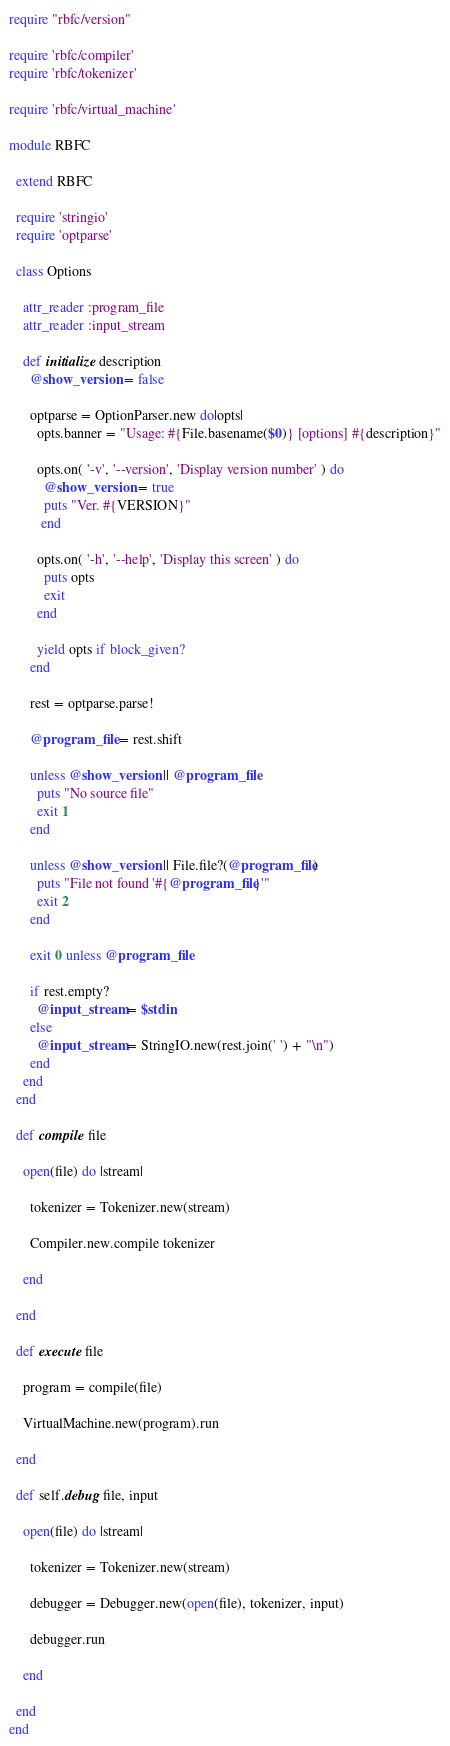Convert code to text. <code><loc_0><loc_0><loc_500><loc_500><_Ruby_>require "rbfc/version"

require 'rbfc/compiler'
require 'rbfc/tokenizer'

require 'rbfc/virtual_machine'

module RBFC

  extend RBFC

  require 'stringio'
  require 'optparse'

  class Options

    attr_reader :program_file
    attr_reader :input_stream

    def initialize description
      @show_version = false

      optparse = OptionParser.new do|opts|
        opts.banner = "Usage: #{File.basename($0)} [options] #{description}"

        opts.on( '-v', '--version', 'Display version number' ) do
          @show_version = true
          puts "Ver. #{VERSION}"
         end

        opts.on( '-h', '--help', 'Display this screen' ) do
          puts opts
          exit
        end

        yield opts if block_given?
      end

      rest = optparse.parse!

      @program_file = rest.shift

      unless @show_version || @program_file
        puts "No source file"
        exit 1
      end

      unless @show_version || File.file?(@program_file)
        puts "File not found '#{@program_file}'"
        exit 2
      end

      exit 0 unless @program_file

      if rest.empty?
        @input_stream = $stdin
      else
        @input_stream = StringIO.new(rest.join(' ') + "\n")
      end
    end
  end

  def compile file

    open(file) do |stream|

      tokenizer = Tokenizer.new(stream)

      Compiler.new.compile tokenizer

    end

  end

  def execute file

    program = compile(file)

    VirtualMachine.new(program).run

  end

  def self.debug file, input

    open(file) do |stream|

      tokenizer = Tokenizer.new(stream)

      debugger = Debugger.new(open(file), tokenizer, input)

      debugger.run

    end

  end
end
</code> 